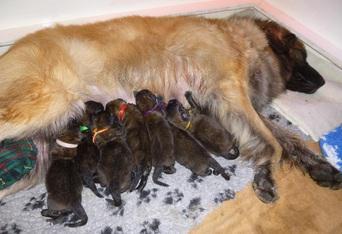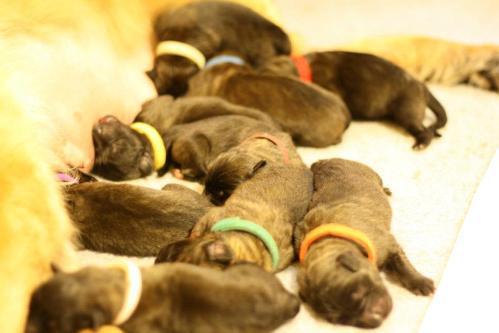The first image is the image on the left, the second image is the image on the right. For the images displayed, is the sentence "Puppies are nursing on a puppy paw print rug in one of the images." factually correct? Answer yes or no. Yes. The first image is the image on the left, the second image is the image on the right. Analyze the images presented: Is the assertion "An image shows multiple puppies on a gray rug with a paw print pattern." valid? Answer yes or no. Yes. 